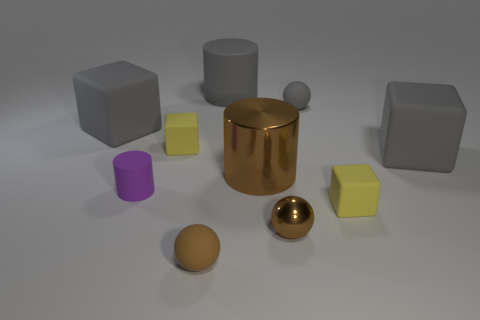There is a big object that is on the left side of the tiny cylinder; does it have the same color as the large metallic object?
Make the answer very short. No. How many things are either matte blocks that are right of the small gray matte object or blocks on the left side of the tiny purple cylinder?
Ensure brevity in your answer.  3. How many tiny objects are both on the right side of the small purple cylinder and on the left side of the small brown metallic ball?
Offer a very short reply. 2. Is the small gray sphere made of the same material as the brown cylinder?
Offer a very short reply. No. There is a small yellow matte thing that is to the left of the matte ball in front of the big gray rubber object left of the gray rubber cylinder; what shape is it?
Provide a succinct answer. Cube. What is the material of the object that is on the left side of the tiny brown matte thing and to the right of the tiny purple cylinder?
Provide a succinct answer. Rubber. There is a small block that is right of the large matte object behind the big matte block to the left of the small cylinder; what is its color?
Give a very brief answer. Yellow. What number of yellow objects are large matte cylinders or rubber objects?
Your answer should be very brief. 2. What number of other things are the same size as the gray cylinder?
Your answer should be compact. 3. How many gray objects are there?
Offer a terse response. 4. 